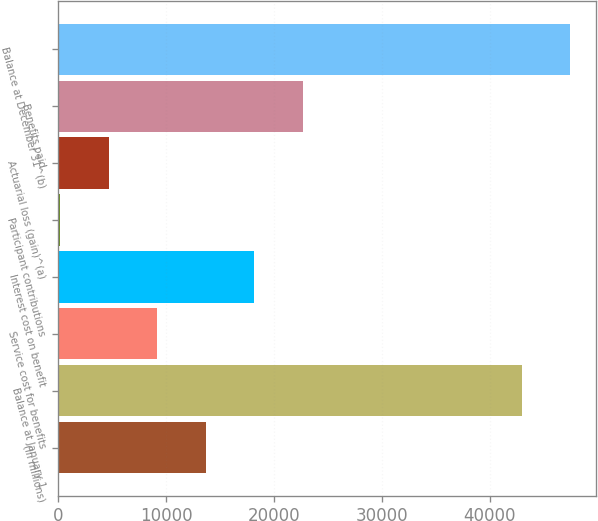Convert chart to OTSL. <chart><loc_0><loc_0><loc_500><loc_500><bar_chart><fcel>(In millions)<fcel>Balance at January 1<fcel>Service cost for benefits<fcel>Interest cost on benefit<fcel>Participant contributions<fcel>Actuarial loss (gain)^(a)<fcel>Benefits paid<fcel>Balance at December 31^(b)<nl><fcel>13668.7<fcel>42947<fcel>9168.8<fcel>18168.6<fcel>169<fcel>4668.9<fcel>22668.5<fcel>47446.9<nl></chart> 